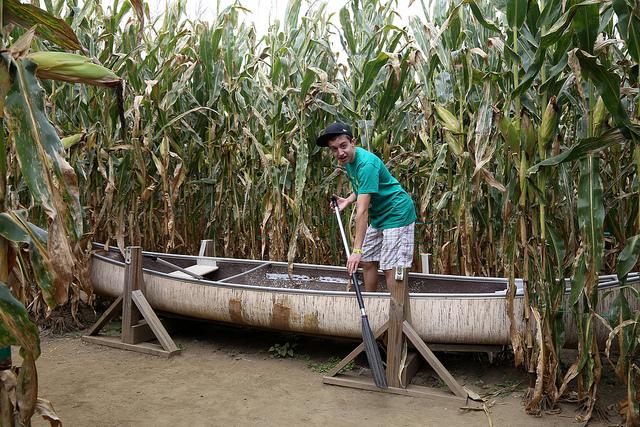Is he wasting his time?
Keep it brief. Yes. Does this person believe he is in a body of water?
Concise answer only. No. What type of plant is surrounding the boat?
Keep it brief. Corn. 